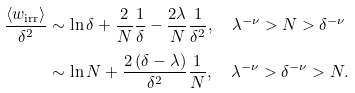<formula> <loc_0><loc_0><loc_500><loc_500>\frac { \left \langle w _ { \text {irr} } \right \rangle } { \delta ^ { 2 } } & \sim \ln \delta + \frac { 2 } { N } \frac { 1 } { \delta } - \frac { 2 \lambda } { N } \frac { 1 } { \delta ^ { 2 } } , \quad \lambda ^ { - \nu } > N > \delta ^ { - \nu } \\ & \sim \ln N + \frac { 2 \left ( \delta - \lambda \right ) } { \delta ^ { 2 } } \frac { 1 } { N } , \quad \lambda ^ { - \nu } > \delta ^ { - \nu } > N .</formula> 